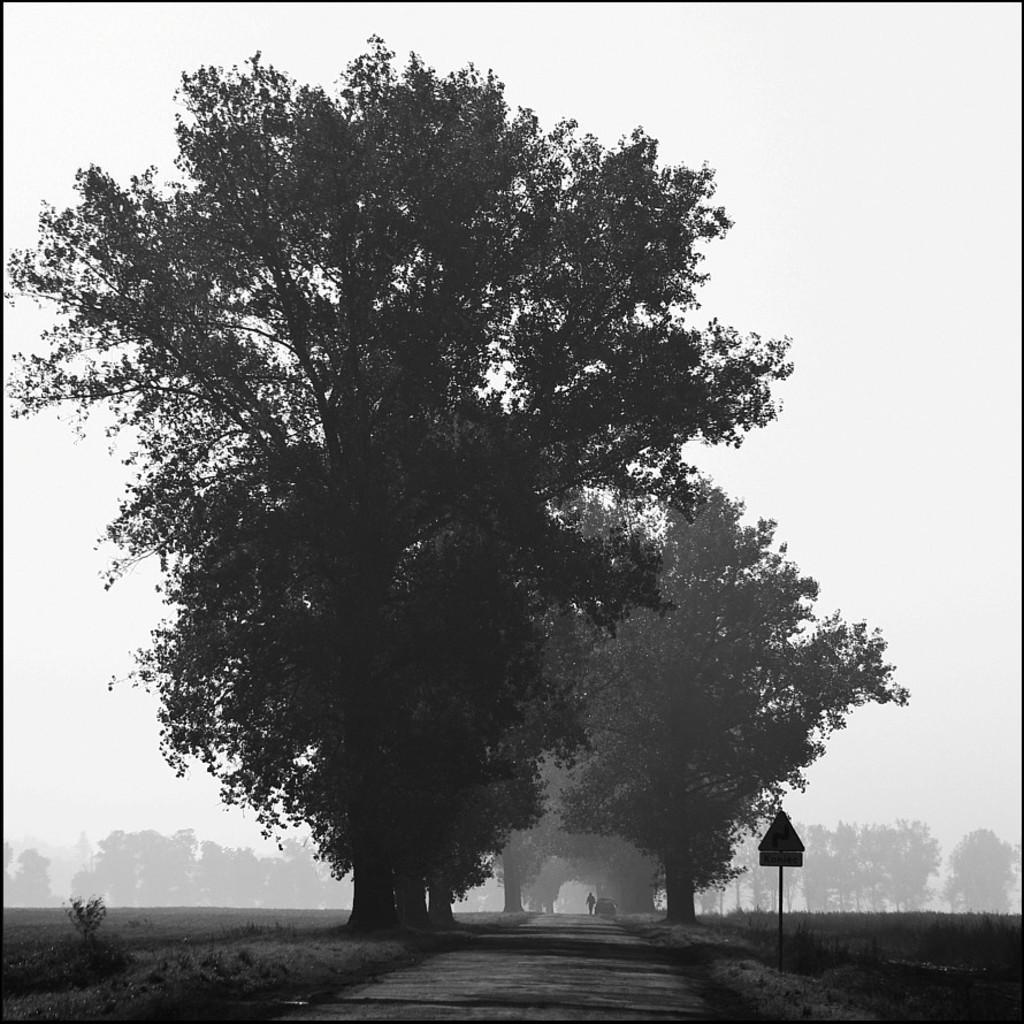Could you give a brief overview of what you see in this image? In this image I can see the black and white picture in which I can see the road, a person and the vehicle on the road, a pole and a sign board attached to the pole and few trees. In the background I can see few trees and the sky. 